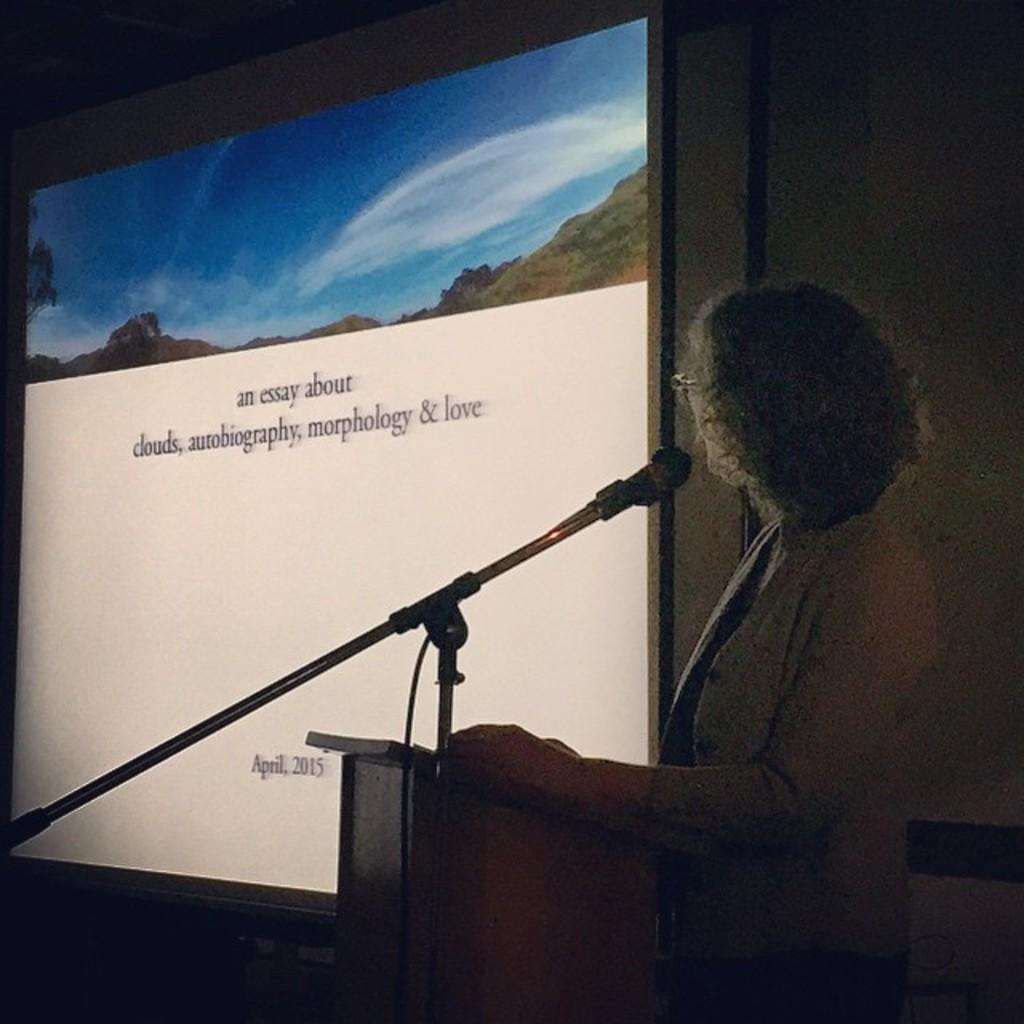Please provide a concise description of this image. In this image we can see a woman wearing blazer is standing at the podium where a mic to the stand is kept. The background of the image is dark where we can see the projector screen on which we can see something is displayed in which we can see the mountains and the blue color sky with clouds, here we can see some text. 